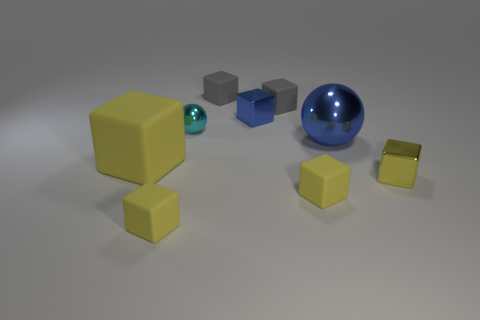What shape is the shiny thing that is the same color as the big matte object?
Your answer should be very brief. Cube. There is a blue metal object that is the same size as the yellow shiny object; what shape is it?
Your answer should be compact. Cube. There is a block that is the same color as the big sphere; what is its material?
Your response must be concise. Metal. There is a large shiny thing; are there any tiny metallic objects in front of it?
Provide a succinct answer. Yes. Are there any big things that have the same shape as the tiny cyan object?
Provide a short and direct response. Yes. Is the shape of the small yellow shiny object in front of the big matte cube the same as the big object on the left side of the large sphere?
Ensure brevity in your answer.  Yes. Are there any yellow rubber cylinders that have the same size as the blue metal block?
Make the answer very short. No. Is the number of small blue metal blocks that are behind the tiny cyan sphere the same as the number of matte objects on the right side of the blue metal sphere?
Offer a terse response. No. Are the small thing to the left of the cyan thing and the big object to the left of the large shiny object made of the same material?
Your answer should be compact. Yes. What is the big yellow object made of?
Your answer should be very brief. Rubber. 